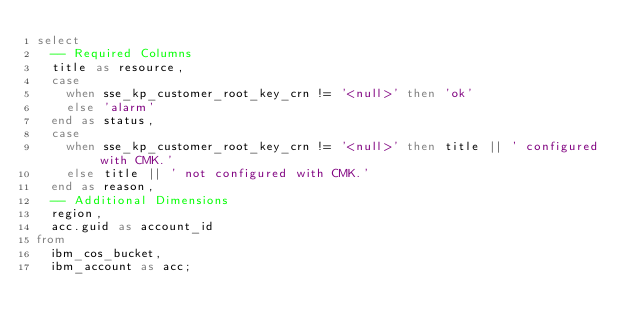Convert code to text. <code><loc_0><loc_0><loc_500><loc_500><_SQL_>select
  -- Required Columns
  title as resource,
  case
    when sse_kp_customer_root_key_crn != '<null>' then 'ok'
    else 'alarm'
  end as status,
  case
    when sse_kp_customer_root_key_crn != '<null>' then title || ' configured with CMK.'
    else title || ' not configured with CMK.'
  end as reason,
  -- Additional Dimensions
  region,
  acc.guid as account_id
from
  ibm_cos_bucket,
  ibm_account as acc;</code> 